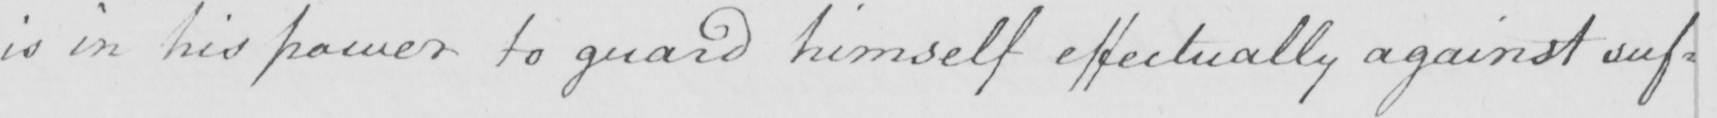Can you read and transcribe this handwriting? is in his power to guard himself effectually against suf= 